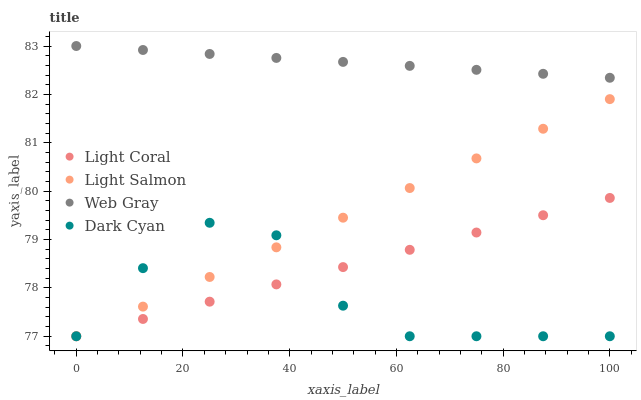Does Dark Cyan have the minimum area under the curve?
Answer yes or no. Yes. Does Web Gray have the maximum area under the curve?
Answer yes or no. Yes. Does Light Salmon have the minimum area under the curve?
Answer yes or no. No. Does Light Salmon have the maximum area under the curve?
Answer yes or no. No. Is Light Salmon the smoothest?
Answer yes or no. Yes. Is Dark Cyan the roughest?
Answer yes or no. Yes. Is Dark Cyan the smoothest?
Answer yes or no. No. Is Light Salmon the roughest?
Answer yes or no. No. Does Light Coral have the lowest value?
Answer yes or no. Yes. Does Web Gray have the lowest value?
Answer yes or no. No. Does Web Gray have the highest value?
Answer yes or no. Yes. Does Light Salmon have the highest value?
Answer yes or no. No. Is Light Salmon less than Web Gray?
Answer yes or no. Yes. Is Web Gray greater than Dark Cyan?
Answer yes or no. Yes. Does Light Coral intersect Light Salmon?
Answer yes or no. Yes. Is Light Coral less than Light Salmon?
Answer yes or no. No. Is Light Coral greater than Light Salmon?
Answer yes or no. No. Does Light Salmon intersect Web Gray?
Answer yes or no. No. 